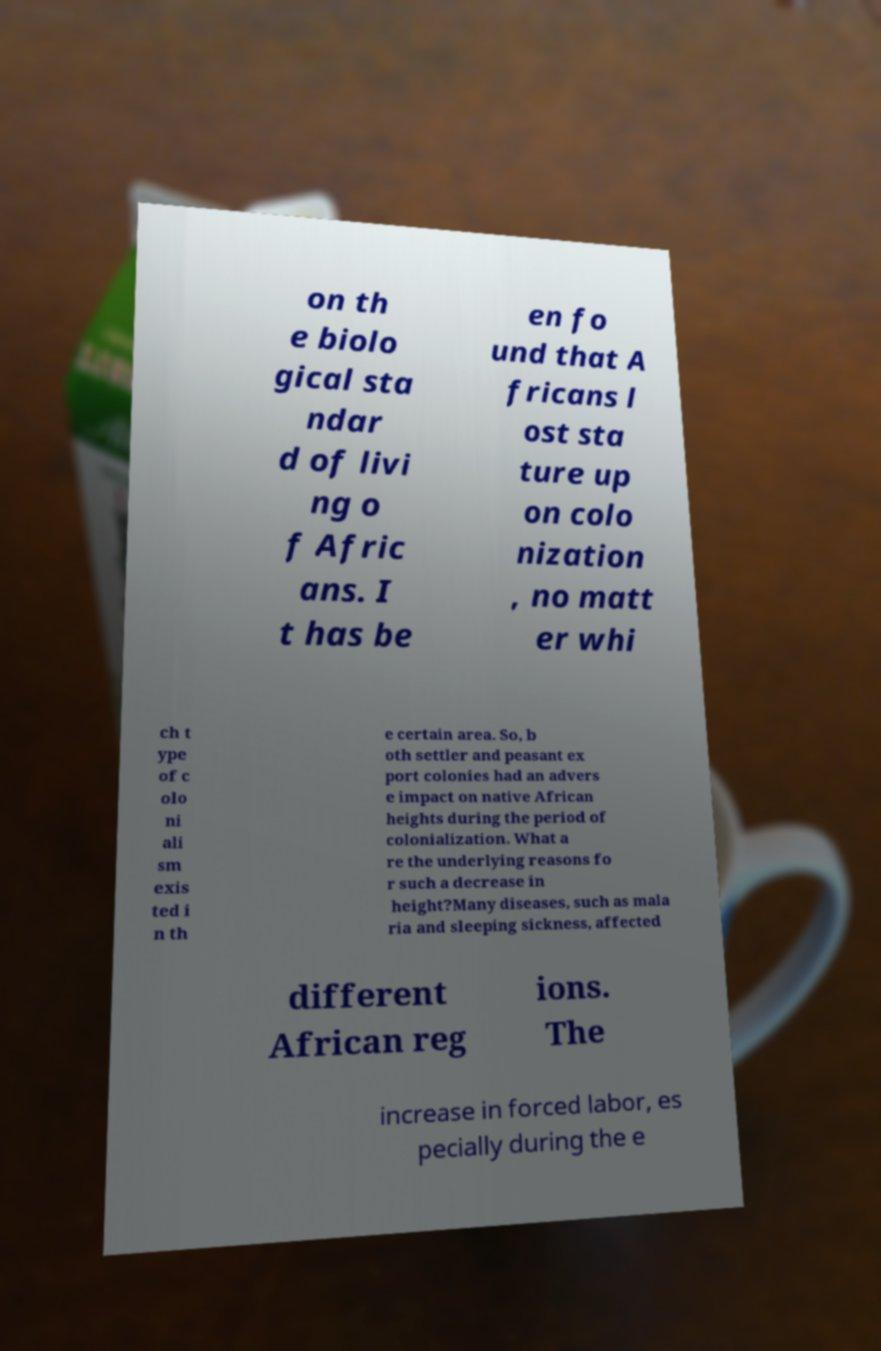Please identify and transcribe the text found in this image. on th e biolo gical sta ndar d of livi ng o f Afric ans. I t has be en fo und that A fricans l ost sta ture up on colo nization , no matt er whi ch t ype of c olo ni ali sm exis ted i n th e certain area. So, b oth settler and peasant ex port colonies had an advers e impact on native African heights during the period of colonialization. What a re the underlying reasons fo r such a decrease in height?Many diseases, such as mala ria and sleeping sickness, affected different African reg ions. The increase in forced labor, es pecially during the e 